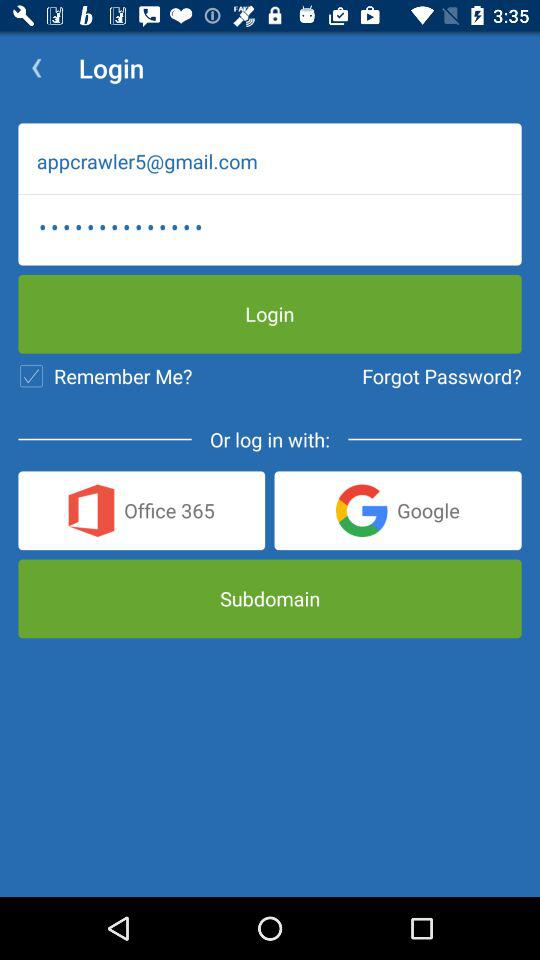What is the status of "Remember Me"? The status is "on". 